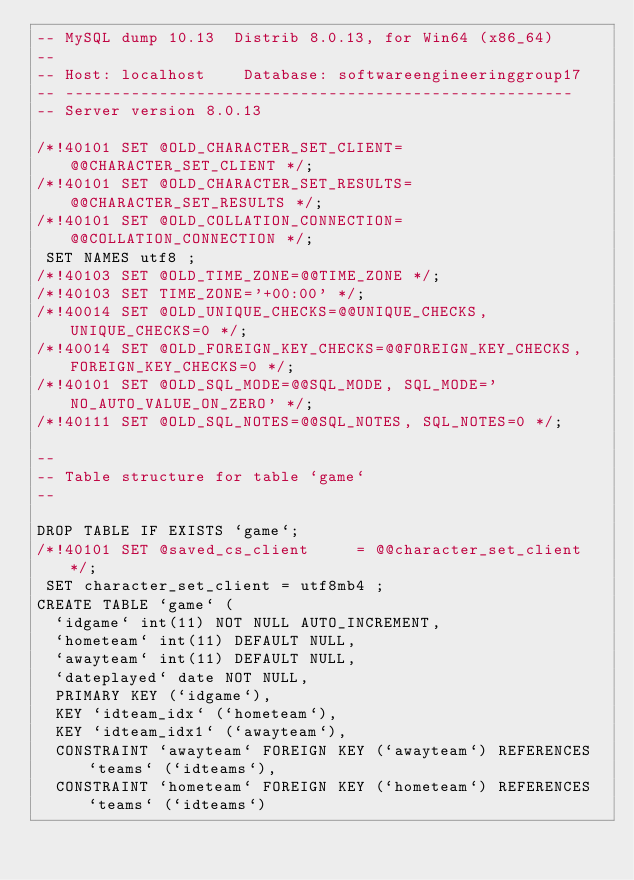<code> <loc_0><loc_0><loc_500><loc_500><_SQL_>-- MySQL dump 10.13  Distrib 8.0.13, for Win64 (x86_64)
--
-- Host: localhost    Database: softwareengineeringgroup17
-- ------------------------------------------------------
-- Server version	8.0.13

/*!40101 SET @OLD_CHARACTER_SET_CLIENT=@@CHARACTER_SET_CLIENT */;
/*!40101 SET @OLD_CHARACTER_SET_RESULTS=@@CHARACTER_SET_RESULTS */;
/*!40101 SET @OLD_COLLATION_CONNECTION=@@COLLATION_CONNECTION */;
 SET NAMES utf8 ;
/*!40103 SET @OLD_TIME_ZONE=@@TIME_ZONE */;
/*!40103 SET TIME_ZONE='+00:00' */;
/*!40014 SET @OLD_UNIQUE_CHECKS=@@UNIQUE_CHECKS, UNIQUE_CHECKS=0 */;
/*!40014 SET @OLD_FOREIGN_KEY_CHECKS=@@FOREIGN_KEY_CHECKS, FOREIGN_KEY_CHECKS=0 */;
/*!40101 SET @OLD_SQL_MODE=@@SQL_MODE, SQL_MODE='NO_AUTO_VALUE_ON_ZERO' */;
/*!40111 SET @OLD_SQL_NOTES=@@SQL_NOTES, SQL_NOTES=0 */;

--
-- Table structure for table `game`
--

DROP TABLE IF EXISTS `game`;
/*!40101 SET @saved_cs_client     = @@character_set_client */;
 SET character_set_client = utf8mb4 ;
CREATE TABLE `game` (
  `idgame` int(11) NOT NULL AUTO_INCREMENT,
  `hometeam` int(11) DEFAULT NULL,
  `awayteam` int(11) DEFAULT NULL,
  `dateplayed` date NOT NULL,
  PRIMARY KEY (`idgame`),
  KEY `idteam_idx` (`hometeam`),
  KEY `idteam_idx1` (`awayteam`),
  CONSTRAINT `awayteam` FOREIGN KEY (`awayteam`) REFERENCES `teams` (`idteams`),
  CONSTRAINT `hometeam` FOREIGN KEY (`hometeam`) REFERENCES `teams` (`idteams`)</code> 